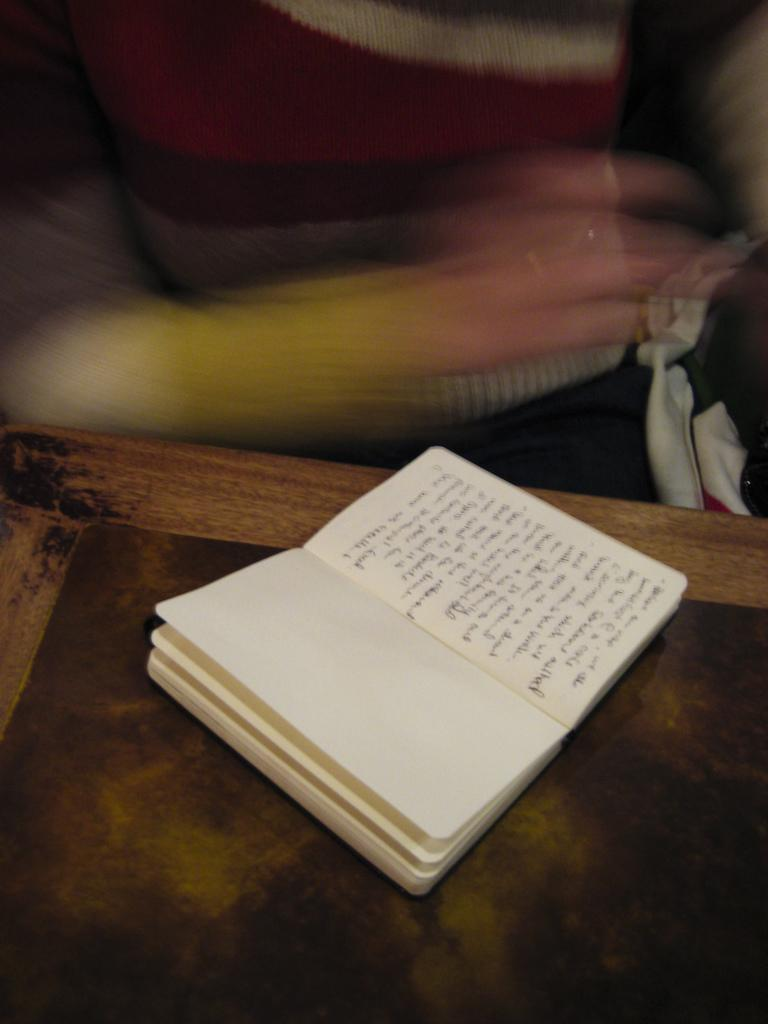What is present on the table in the image? There is a book and something written on a paper on the table in the image. What is the person in the image doing? The person in the image is visible, although blurry, but their actions cannot be determined from the image. Can you describe the book in the image? The book is on the table, but no further details about its appearance or content can be determined from the image. What type of pan is the person using to express their anger in the image? There is no pan or expression of anger present in the image. Can you describe the kiss between the two people in the image? There are no people kissing in the image; only a book, a paper, and a blurry person are visible. 